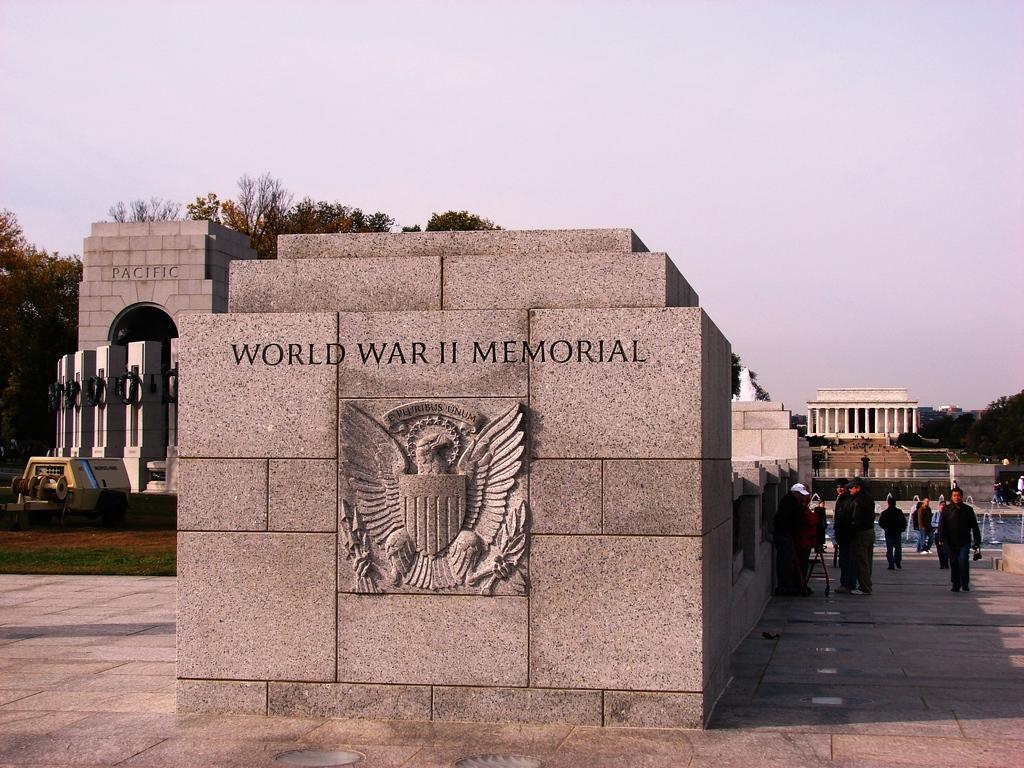How would you summarize this image in a sentence or two? In this picture there is a stone architecture in the center. On the stone, there is a picture engraved on it. Towards the right, there are people moving around. Towards the left there is a architecture and a vehicle. In the background there are buildings, trees and a sky. 